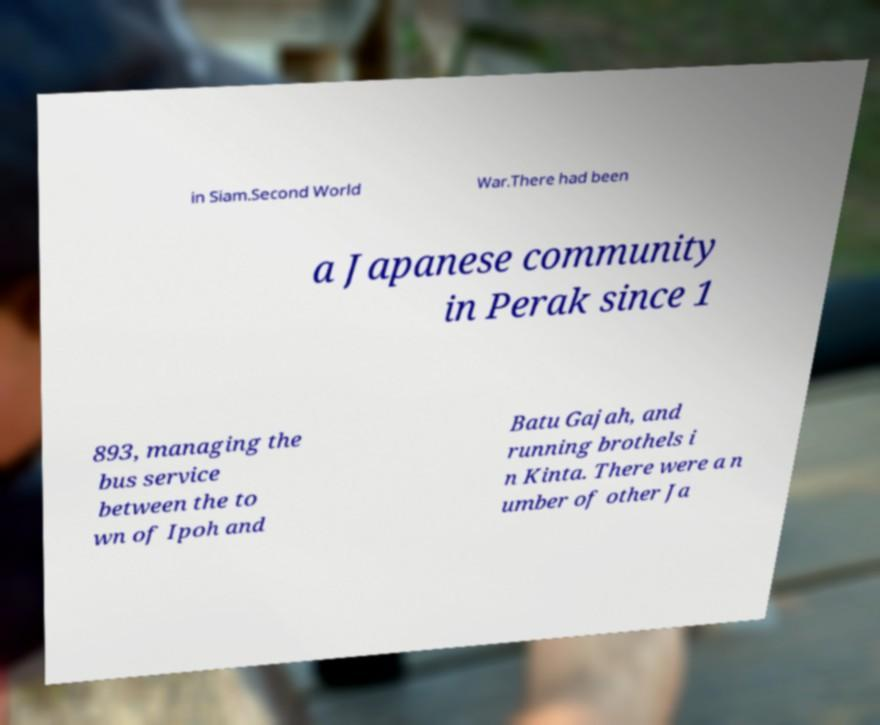Could you extract and type out the text from this image? in Siam.Second World War.There had been a Japanese community in Perak since 1 893, managing the bus service between the to wn of Ipoh and Batu Gajah, and running brothels i n Kinta. There were a n umber of other Ja 